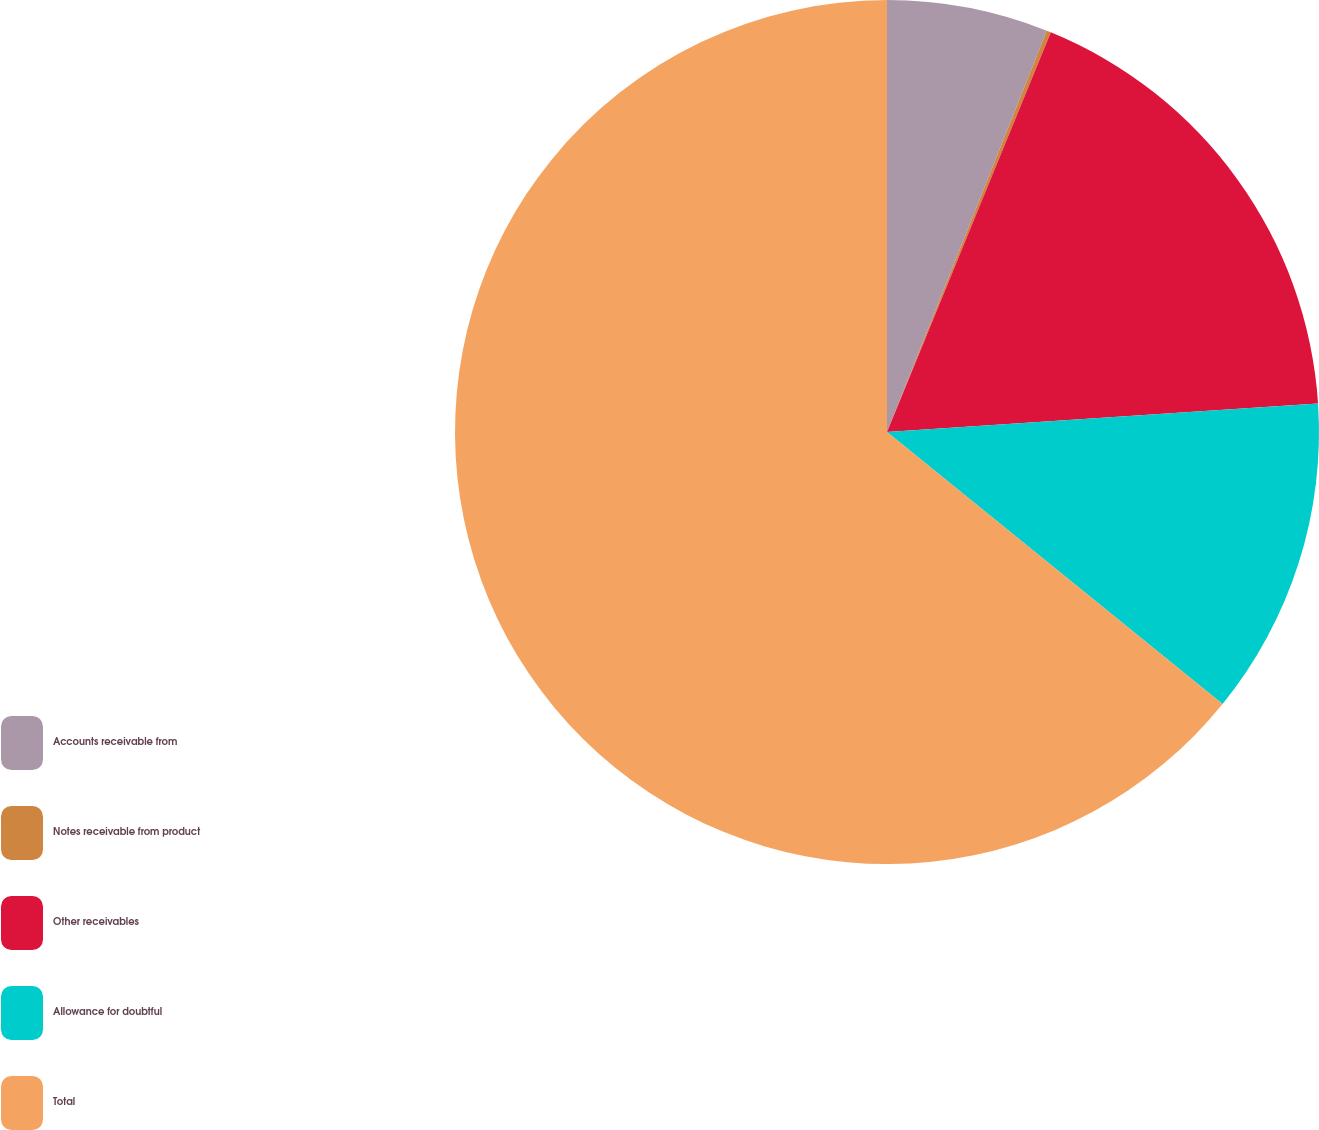Convert chart. <chart><loc_0><loc_0><loc_500><loc_500><pie_chart><fcel>Accounts receivable from<fcel>Notes receivable from product<fcel>Other receivables<fcel>Allowance for doubtful<fcel>Total<nl><fcel>6.03%<fcel>0.16%<fcel>17.76%<fcel>11.89%<fcel>64.15%<nl></chart> 